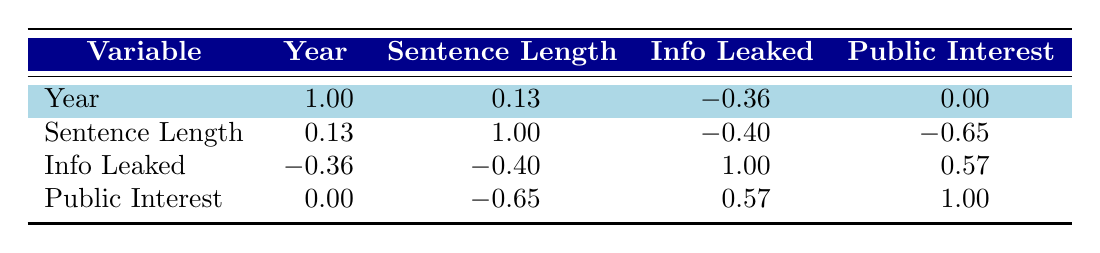What is the sentence length for United States v. Reality Winner? From the table, you can directly find that the sentence length for this case is listed under "Sentence Length" in the row corresponding to "United States v. Reality Winner." The value is 63 months.
Answer: 63 months Is there a correlation between the length of the sentence and the amount of classified information leaked? Looking at the table, the correlation coefficient for "Sentence Length" and "Info Leaked" is -0.40. A negative value indicates that there is an inverse correlation between these two variables.
Answer: Yes, there is a negative correlation What is the average sentence length for the cases where public interest defense was used? To answer this, we need to identify the cases where "Public Interest" is equal to 1, which are United States v. Daniel Hale, United States v. Reality Winner, United States v. Chelsea Manning. Their sentence lengths are 45, 63, and 35 months respectively. We sum these lengths (45 + 63 + 35 = 143) and divide by the number of cases (3). The average is 143 / 3 = 47.67 months.
Answer: 47.67 months Was there a conviction in the case of United States v. Edward Snowden? The conviction status is found in the "Conviction" column for the case "United States v. Edward Snowden." The value given is false, indicating that there was no conviction in this case.
Answer: No What is the total amount of classified information leaked in the convictions? We need to examine the rows of cases where "Conviction" is true: United States v. Daniel Hale (5), United States v. Reality Winner (1), United States v. Chelsea Manning (750), United States v. John Kiriakou (3), and United States v. Jeffrey Sterling (1). Summing these values yields 5 + 1 + 750 + 3 + 1 = 760.
Answer: 760 